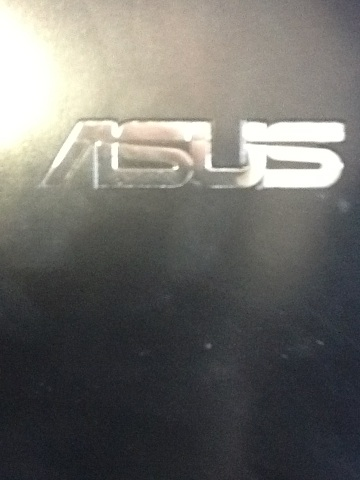What is this? This is an image showing the logo of the technology company Asus. It appears to be taken from an electronic device, possibly a laptop or a computer monitor. 